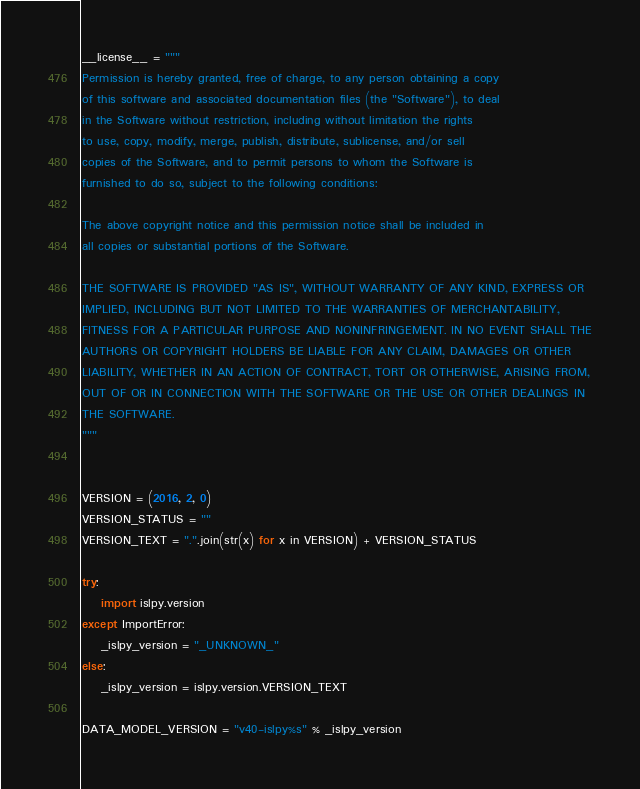Convert code to text. <code><loc_0><loc_0><loc_500><loc_500><_Python_>__license__ = """
Permission is hereby granted, free of charge, to any person obtaining a copy
of this software and associated documentation files (the "Software"), to deal
in the Software without restriction, including without limitation the rights
to use, copy, modify, merge, publish, distribute, sublicense, and/or sell
copies of the Software, and to permit persons to whom the Software is
furnished to do so, subject to the following conditions:

The above copyright notice and this permission notice shall be included in
all copies or substantial portions of the Software.

THE SOFTWARE IS PROVIDED "AS IS", WITHOUT WARRANTY OF ANY KIND, EXPRESS OR
IMPLIED, INCLUDING BUT NOT LIMITED TO THE WARRANTIES OF MERCHANTABILITY,
FITNESS FOR A PARTICULAR PURPOSE AND NONINFRINGEMENT. IN NO EVENT SHALL THE
AUTHORS OR COPYRIGHT HOLDERS BE LIABLE FOR ANY CLAIM, DAMAGES OR OTHER
LIABILITY, WHETHER IN AN ACTION OF CONTRACT, TORT OR OTHERWISE, ARISING FROM,
OUT OF OR IN CONNECTION WITH THE SOFTWARE OR THE USE OR OTHER DEALINGS IN
THE SOFTWARE.
"""


VERSION = (2016, 2, 0)
VERSION_STATUS = ""
VERSION_TEXT = ".".join(str(x) for x in VERSION) + VERSION_STATUS

try:
    import islpy.version
except ImportError:
    _islpy_version = "_UNKNOWN_"
else:
    _islpy_version = islpy.version.VERSION_TEXT

DATA_MODEL_VERSION = "v40-islpy%s" % _islpy_version
</code> 